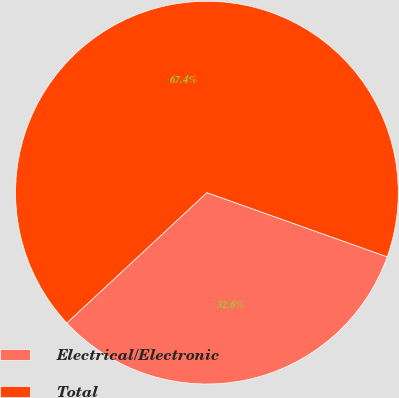<chart> <loc_0><loc_0><loc_500><loc_500><pie_chart><fcel>Electrical/Electronic<fcel>Total<nl><fcel>32.63%<fcel>67.37%<nl></chart> 